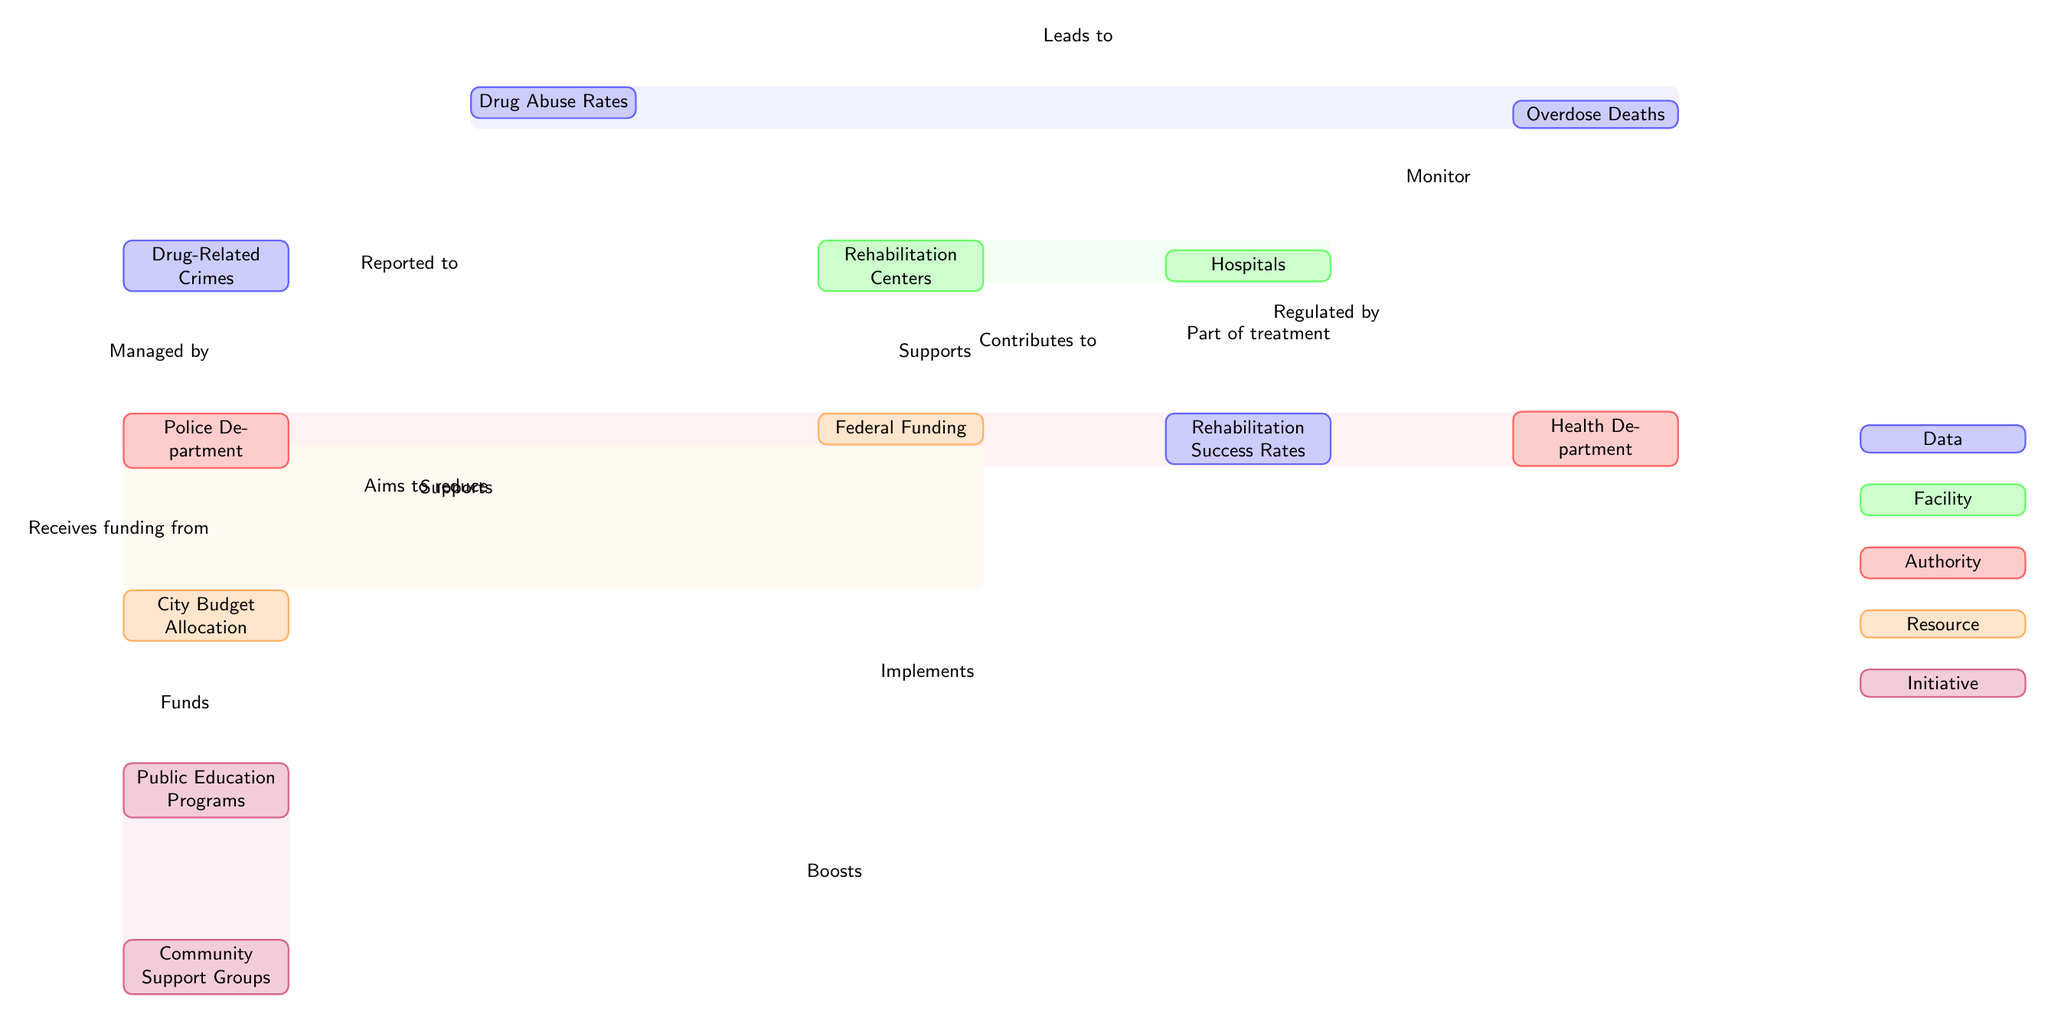What's the main topic of the diagram? The diagram illustrates the relationships and statistics surrounding drug abuse and rehabilitation in the local area. This can be identified by the key node labeled "Drug Abuse Rates," which connects to several other nodes, indicating its central role in the diagram.
Answer: Drug Abuse Rates How many nodes represent data in the diagram? There are four nodes that represent data: "Drug Abuse Rates," "Drug-Related Crimes," "Overdose Deaths," and "Rehabilitation Success Rates." By counting these specific nodes, one can arrive at the answer.
Answer: 4 What does the Police Department manage? The Police Department manages "Drug-Related Crimes," which is indicated by the edge directed from the "Drug-Related Crimes" node to the "Police Department" node. This illustrates the nature of their responsibilities regarding drug incidents.
Answer: Drug-Related Crimes Which department implements public education programs? The Health Department is responsible for implementing public education programs, as shown by the edge connecting the "Health Department" node to the "Public Education Programs" node. This indicates the department's role in educating the public about drug abuse.
Answer: Health Department What supports rehabilitation centers? "Federal Funding" supports rehabilitation centers, as indicated by the edge that directs from the "Federal Funding" node to the "Rehabilitation Centers" node, showing the financial backing provided to these facilities.
Answer: Federal Funding How do community support groups contribute to rehabilitation success? Community support groups boost the "Rehabilitation Success Rates," which is illustrated by the edge from the "Community Support Groups" node directed toward the "Rehabilitation Success Rates" node, indicating a positive impact on rehabilitation efforts.
Answer: Boosts What type of programs aims to reduce drug abuse? Public education programs aim to reduce drug abuse, as evidenced by the edge from the "Public Education Programs" node toward the "Drug Abuse Rates" node, indicating their role in addressing the issue of drug abuse.
Answer: Public Education Programs How does the City Budget Allocation relate to drug-related activities? The City Budget Allocation funds the "Public Education Programs" and provides resources to the "Police Department," demonstrating its role in regulating drug-related activities. This information involves tracing the edges from the budget node to understand its relationships.
Answer: Funds What type of node is "Rehabilitation Centers"? "Rehabilitation Centers" is classified as a facility node. This classification can be identified in the diagram by observing its label and the specific color coding used for facility categories, distinguishing it from data, authority, resource, and initiative nodes.
Answer: Facility 